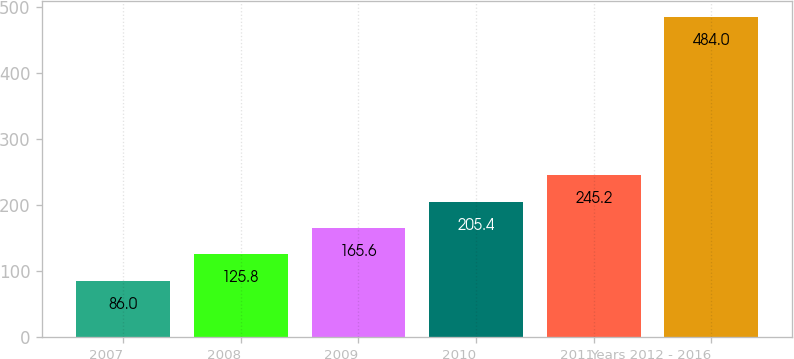Convert chart to OTSL. <chart><loc_0><loc_0><loc_500><loc_500><bar_chart><fcel>2007<fcel>2008<fcel>2009<fcel>2010<fcel>2011<fcel>Years 2012 - 2016<nl><fcel>86<fcel>125.8<fcel>165.6<fcel>205.4<fcel>245.2<fcel>484<nl></chart> 